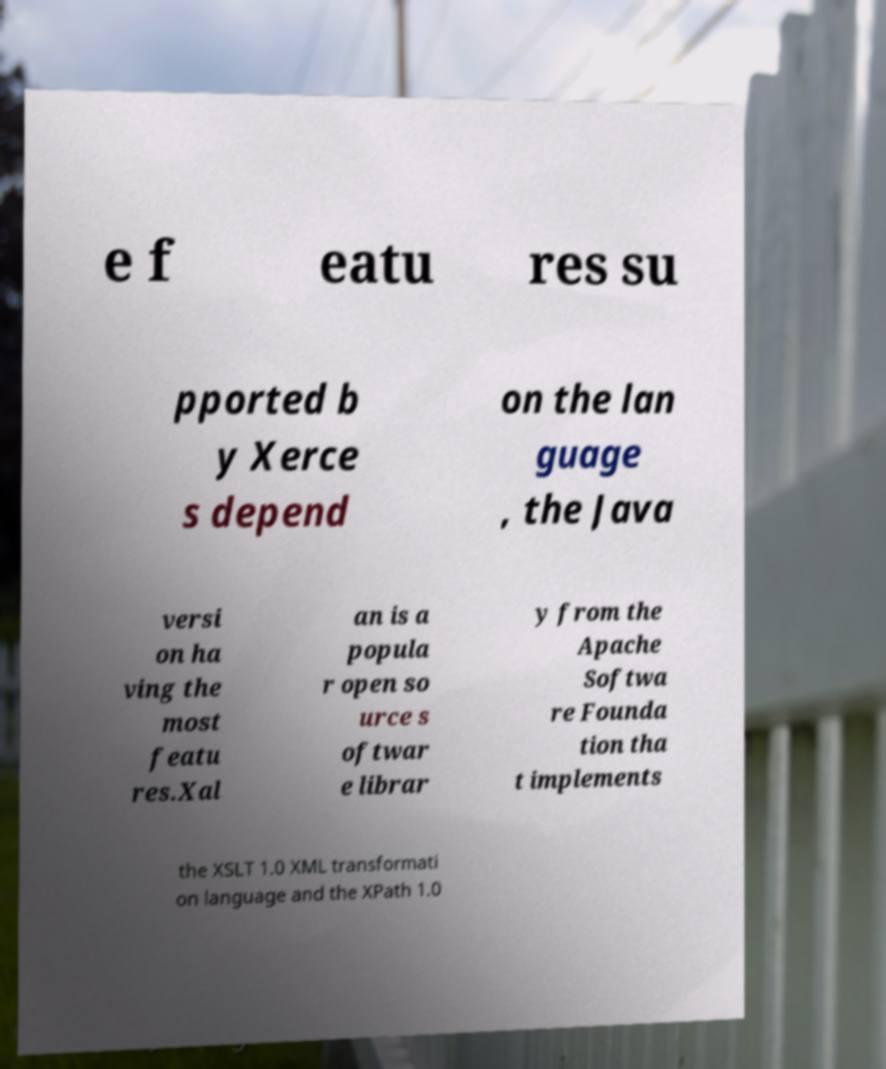For documentation purposes, I need the text within this image transcribed. Could you provide that? e f eatu res su pported b y Xerce s depend on the lan guage , the Java versi on ha ving the most featu res.Xal an is a popula r open so urce s oftwar e librar y from the Apache Softwa re Founda tion tha t implements the XSLT 1.0 XML transformati on language and the XPath 1.0 